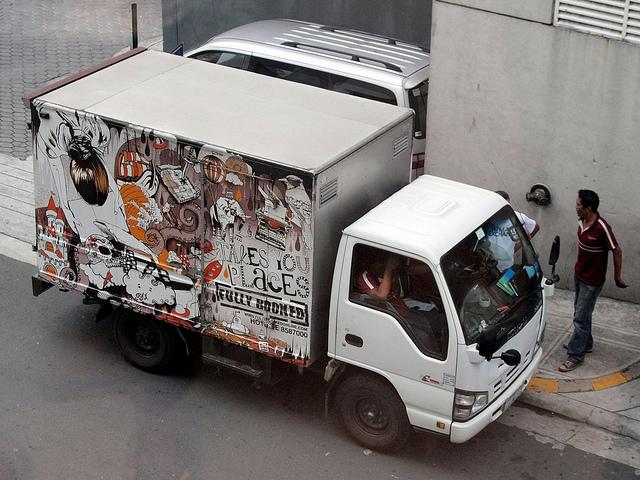How many people can be seen?
Be succinct. 3. Is this truck one solid color?
Concise answer only. No. Will the white van be able to move?
Keep it brief. Yes. 